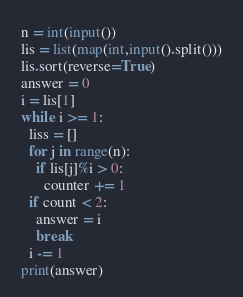<code> <loc_0><loc_0><loc_500><loc_500><_Python_>n = int(input())
lis = list(map(int,input().split()))
lis.sort(reverse=True)
answer = 0
i = lis[1]
while i >= 1:
  liss = []
  for j in range(n):
    if lis[j]%i > 0:
      counter += 1
  if count < 2:
    answer = i
    break
  i -= 1
print(answer)
</code> 